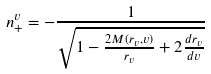Convert formula to latex. <formula><loc_0><loc_0><loc_500><loc_500>n ^ { v } _ { + } = - \frac { 1 } { \sqrt { 1 - \frac { 2 M ( r _ { v } , v ) } { r _ { v } } + 2 \frac { d r _ { v } } { d v } } }</formula> 